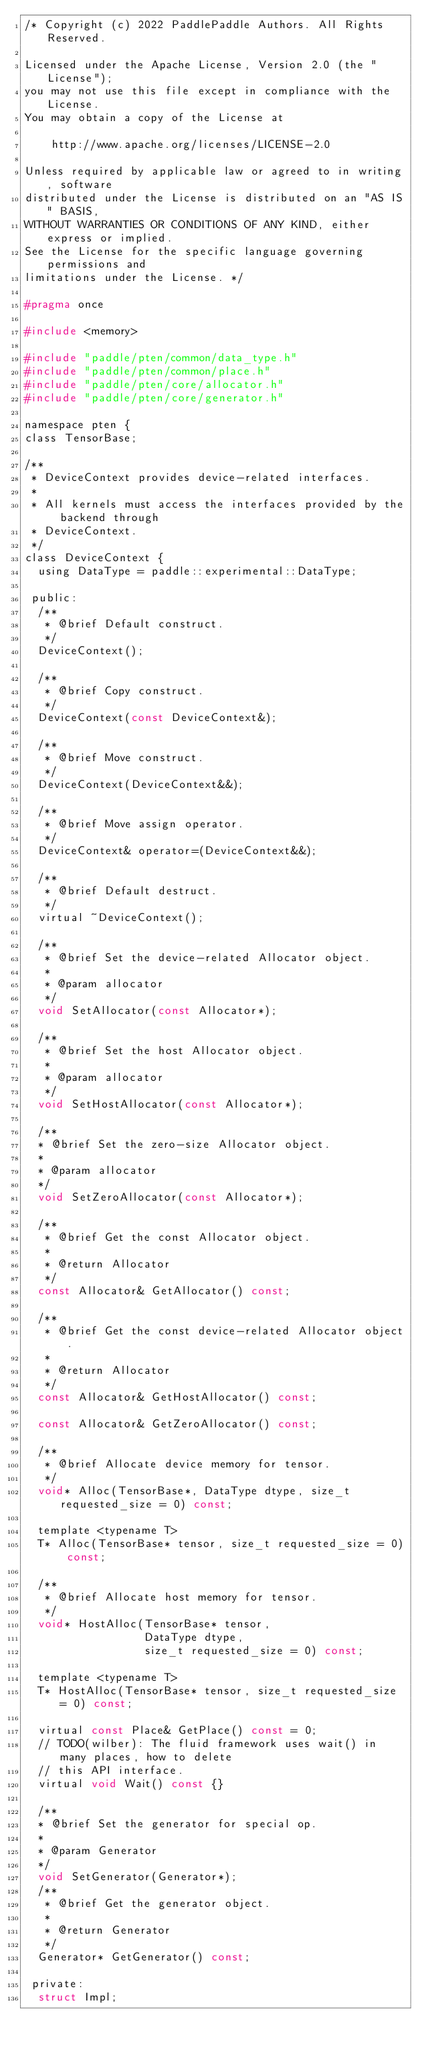<code> <loc_0><loc_0><loc_500><loc_500><_C_>/* Copyright (c) 2022 PaddlePaddle Authors. All Rights Reserved.

Licensed under the Apache License, Version 2.0 (the "License");
you may not use this file except in compliance with the License.
You may obtain a copy of the License at

    http://www.apache.org/licenses/LICENSE-2.0

Unless required by applicable law or agreed to in writing, software
distributed under the License is distributed on an "AS IS" BASIS,
WITHOUT WARRANTIES OR CONDITIONS OF ANY KIND, either express or implied.
See the License for the specific language governing permissions and
limitations under the License. */

#pragma once

#include <memory>

#include "paddle/pten/common/data_type.h"
#include "paddle/pten/common/place.h"
#include "paddle/pten/core/allocator.h"
#include "paddle/pten/core/generator.h"

namespace pten {
class TensorBase;

/**
 * DeviceContext provides device-related interfaces.
 *
 * All kernels must access the interfaces provided by the backend through
 * DeviceContext.
 */
class DeviceContext {
  using DataType = paddle::experimental::DataType;

 public:
  /**
   * @brief Default construct.
   */
  DeviceContext();

  /**
   * @brief Copy construct.
   */
  DeviceContext(const DeviceContext&);

  /**
   * @brief Move construct.
   */
  DeviceContext(DeviceContext&&);

  /**
   * @brief Move assign operator.
   */
  DeviceContext& operator=(DeviceContext&&);

  /**
   * @brief Default destruct.
   */
  virtual ~DeviceContext();

  /**
   * @brief Set the device-related Allocator object.
   *
   * @param allocator
   */
  void SetAllocator(const Allocator*);

  /**
   * @brief Set the host Allocator object.
   *
   * @param allocator
   */
  void SetHostAllocator(const Allocator*);

  /**
  * @brief Set the zero-size Allocator object.
  *
  * @param allocator
  */
  void SetZeroAllocator(const Allocator*);

  /**
   * @brief Get the const Allocator object.
   *
   * @return Allocator
   */
  const Allocator& GetAllocator() const;

  /**
   * @brief Get the const device-related Allocator object.
   *
   * @return Allocator
   */
  const Allocator& GetHostAllocator() const;

  const Allocator& GetZeroAllocator() const;

  /**
   * @brief Allocate device memory for tensor.
   */
  void* Alloc(TensorBase*, DataType dtype, size_t requested_size = 0) const;

  template <typename T>
  T* Alloc(TensorBase* tensor, size_t requested_size = 0) const;

  /**
   * @brief Allocate host memory for tensor.
   */
  void* HostAlloc(TensorBase* tensor,
                  DataType dtype,
                  size_t requested_size = 0) const;

  template <typename T>
  T* HostAlloc(TensorBase* tensor, size_t requested_size = 0) const;

  virtual const Place& GetPlace() const = 0;
  // TODO(wilber): The fluid framework uses wait() in many places, how to delete
  // this API interface.
  virtual void Wait() const {}

  /**
  * @brief Set the generator for special op.
  *
  * @param Generator
  */
  void SetGenerator(Generator*);
  /**
   * @brief Get the generator object.
   *
   * @return Generator
   */
  Generator* GetGenerator() const;

 private:
  struct Impl;</code> 